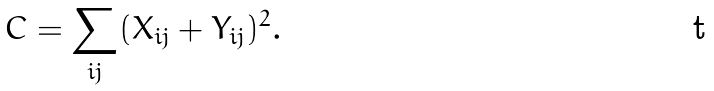Convert formula to latex. <formula><loc_0><loc_0><loc_500><loc_500>C = \sum _ { i j } ( X _ { i j } + Y _ { i j } ) ^ { 2 } .</formula> 